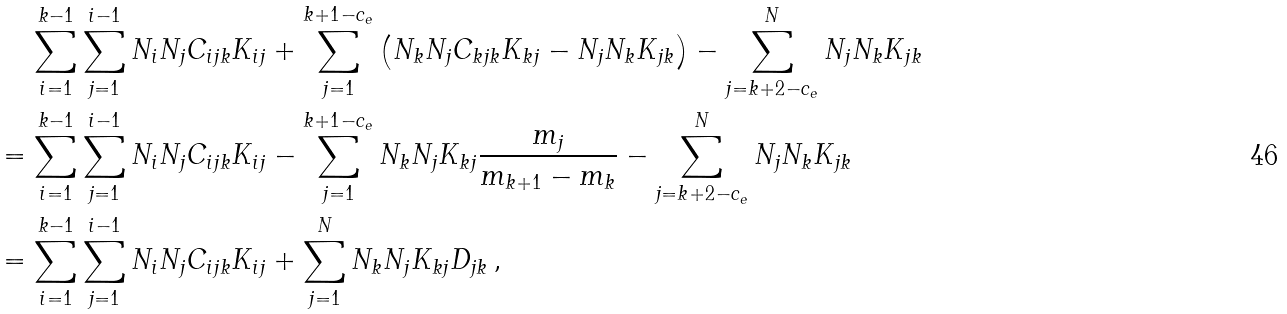<formula> <loc_0><loc_0><loc_500><loc_500>& \quad \, \sum _ { i = 1 } ^ { k - 1 } \sum _ { j = 1 } ^ { i - 1 } N _ { i } N _ { j } C _ { i j k } K _ { i j } + \sum _ { j = 1 } ^ { k + 1 - c _ { e } } \left ( N _ { k } N _ { j } C _ { k j k } K _ { k j } - N _ { j } N _ { k } K _ { j k } \right ) - \sum _ { j = k + 2 - c _ { e } } ^ { N } N _ { j } N _ { k } K _ { j k } \\ & = \sum _ { i = 1 } ^ { k - 1 } \sum _ { j = 1 } ^ { i - 1 } N _ { i } N _ { j } C _ { i j k } K _ { i j } - \sum _ { j = 1 } ^ { k + 1 - c _ { e } } N _ { k } N _ { j } K _ { k j } \frac { m _ { j } } { m _ { k + 1 } - m _ { k } } - \sum _ { j = k + 2 - c _ { e } } ^ { N } N _ { j } N _ { k } K _ { j k } \\ & = \sum _ { i = 1 } ^ { k - 1 } \sum _ { j = 1 } ^ { i - 1 } N _ { i } N _ { j } C _ { i j k } K _ { i j } + \sum _ { j = 1 } ^ { N } N _ { k } N _ { j } K _ { k j } D _ { j k } \, ,</formula> 